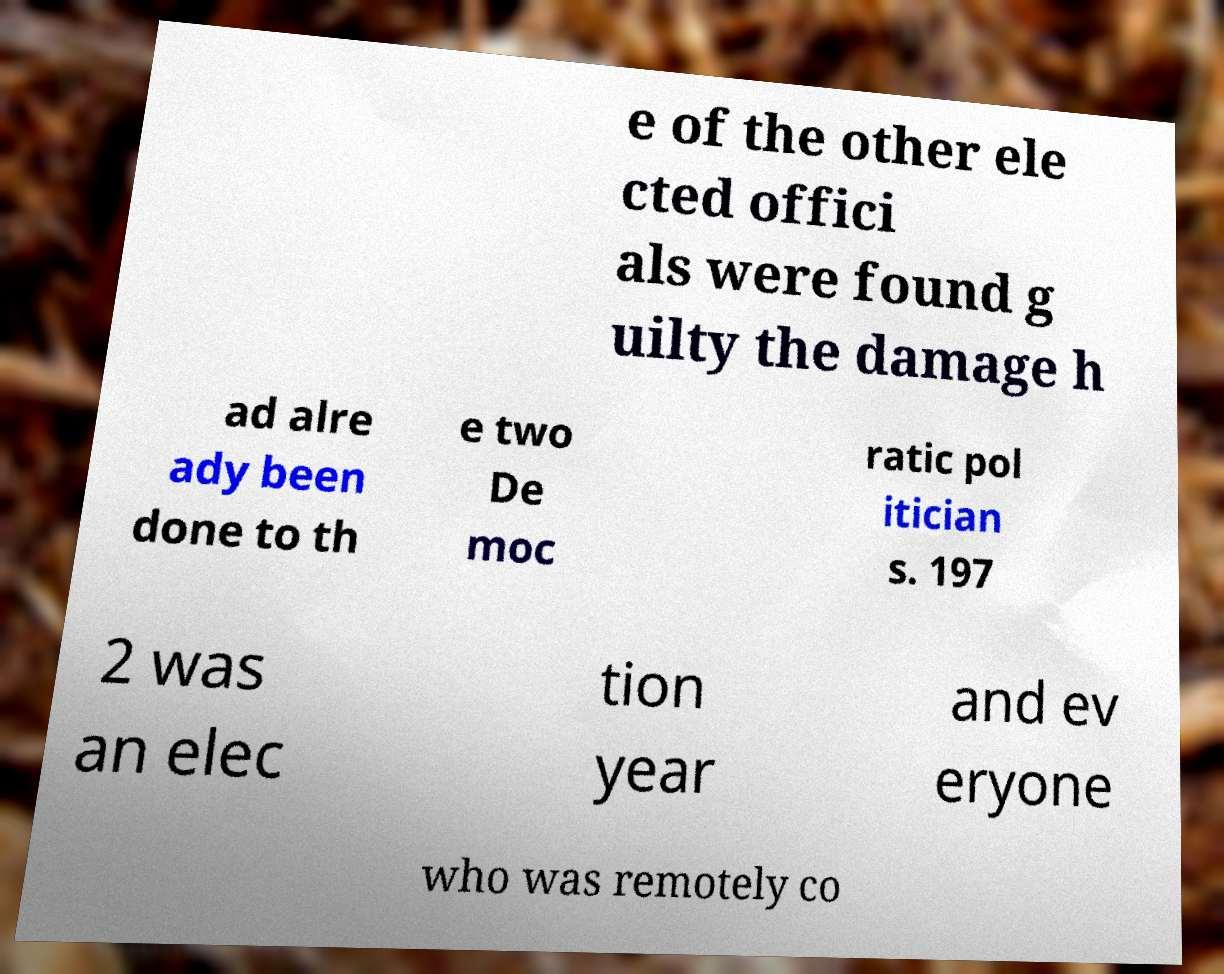Can you read and provide the text displayed in the image?This photo seems to have some interesting text. Can you extract and type it out for me? e of the other ele cted offici als were found g uilty the damage h ad alre ady been done to th e two De moc ratic pol itician s. 197 2 was an elec tion year and ev eryone who was remotely co 